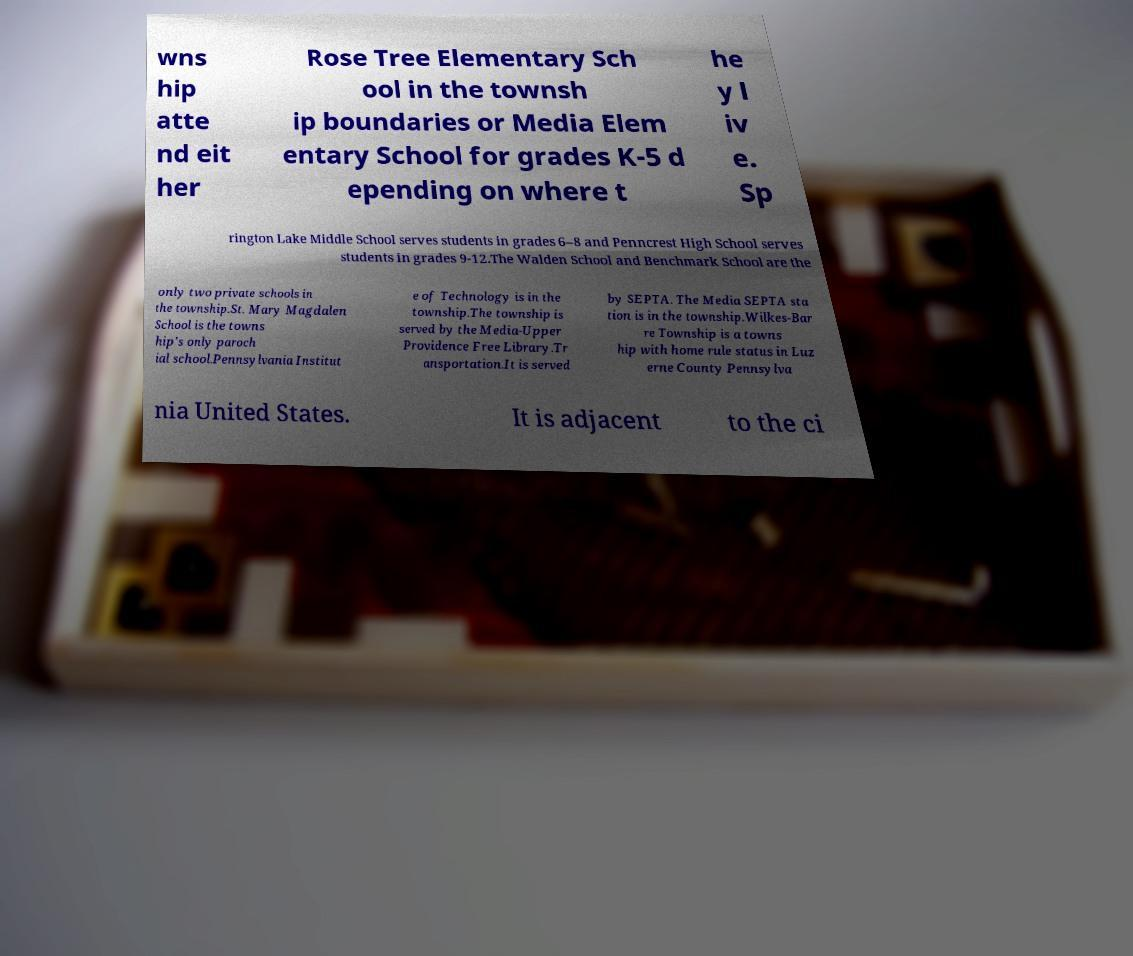Could you extract and type out the text from this image? wns hip atte nd eit her Rose Tree Elementary Sch ool in the townsh ip boundaries or Media Elem entary School for grades K-5 d epending on where t he y l iv e. Sp rington Lake Middle School serves students in grades 6–8 and Penncrest High School serves students in grades 9-12.The Walden School and Benchmark School are the only two private schools in the township.St. Mary Magdalen School is the towns hip's only paroch ial school.Pennsylvania Institut e of Technology is in the township.The township is served by the Media-Upper Providence Free Library.Tr ansportation.It is served by SEPTA. The Media SEPTA sta tion is in the township.Wilkes-Bar re Township is a towns hip with home rule status in Luz erne County Pennsylva nia United States. It is adjacent to the ci 